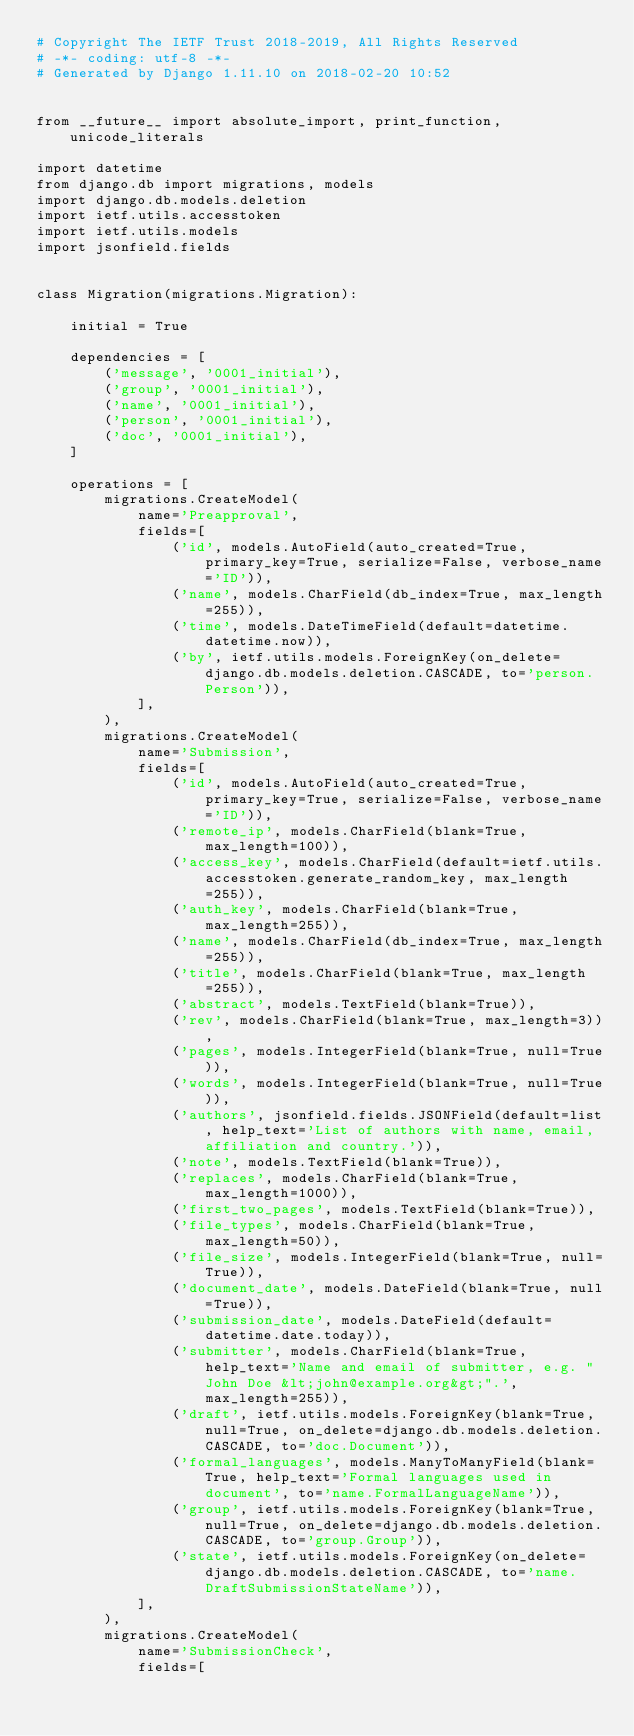<code> <loc_0><loc_0><loc_500><loc_500><_Python_># Copyright The IETF Trust 2018-2019, All Rights Reserved
# -*- coding: utf-8 -*-
# Generated by Django 1.11.10 on 2018-02-20 10:52


from __future__ import absolute_import, print_function, unicode_literals

import datetime
from django.db import migrations, models
import django.db.models.deletion
import ietf.utils.accesstoken
import ietf.utils.models
import jsonfield.fields


class Migration(migrations.Migration):

    initial = True

    dependencies = [
        ('message', '0001_initial'),
        ('group', '0001_initial'),
        ('name', '0001_initial'),
        ('person', '0001_initial'),
        ('doc', '0001_initial'),
    ]

    operations = [
        migrations.CreateModel(
            name='Preapproval',
            fields=[
                ('id', models.AutoField(auto_created=True, primary_key=True, serialize=False, verbose_name='ID')),
                ('name', models.CharField(db_index=True, max_length=255)),
                ('time', models.DateTimeField(default=datetime.datetime.now)),
                ('by', ietf.utils.models.ForeignKey(on_delete=django.db.models.deletion.CASCADE, to='person.Person')),
            ],
        ),
        migrations.CreateModel(
            name='Submission',
            fields=[
                ('id', models.AutoField(auto_created=True, primary_key=True, serialize=False, verbose_name='ID')),
                ('remote_ip', models.CharField(blank=True, max_length=100)),
                ('access_key', models.CharField(default=ietf.utils.accesstoken.generate_random_key, max_length=255)),
                ('auth_key', models.CharField(blank=True, max_length=255)),
                ('name', models.CharField(db_index=True, max_length=255)),
                ('title', models.CharField(blank=True, max_length=255)),
                ('abstract', models.TextField(blank=True)),
                ('rev', models.CharField(blank=True, max_length=3)),
                ('pages', models.IntegerField(blank=True, null=True)),
                ('words', models.IntegerField(blank=True, null=True)),
                ('authors', jsonfield.fields.JSONField(default=list, help_text='List of authors with name, email, affiliation and country.')),
                ('note', models.TextField(blank=True)),
                ('replaces', models.CharField(blank=True, max_length=1000)),
                ('first_two_pages', models.TextField(blank=True)),
                ('file_types', models.CharField(blank=True, max_length=50)),
                ('file_size', models.IntegerField(blank=True, null=True)),
                ('document_date', models.DateField(blank=True, null=True)),
                ('submission_date', models.DateField(default=datetime.date.today)),
                ('submitter', models.CharField(blank=True, help_text='Name and email of submitter, e.g. "John Doe &lt;john@example.org&gt;".', max_length=255)),
                ('draft', ietf.utils.models.ForeignKey(blank=True, null=True, on_delete=django.db.models.deletion.CASCADE, to='doc.Document')),
                ('formal_languages', models.ManyToManyField(blank=True, help_text='Formal languages used in document', to='name.FormalLanguageName')),
                ('group', ietf.utils.models.ForeignKey(blank=True, null=True, on_delete=django.db.models.deletion.CASCADE, to='group.Group')),
                ('state', ietf.utils.models.ForeignKey(on_delete=django.db.models.deletion.CASCADE, to='name.DraftSubmissionStateName')),
            ],
        ),
        migrations.CreateModel(
            name='SubmissionCheck',
            fields=[</code> 